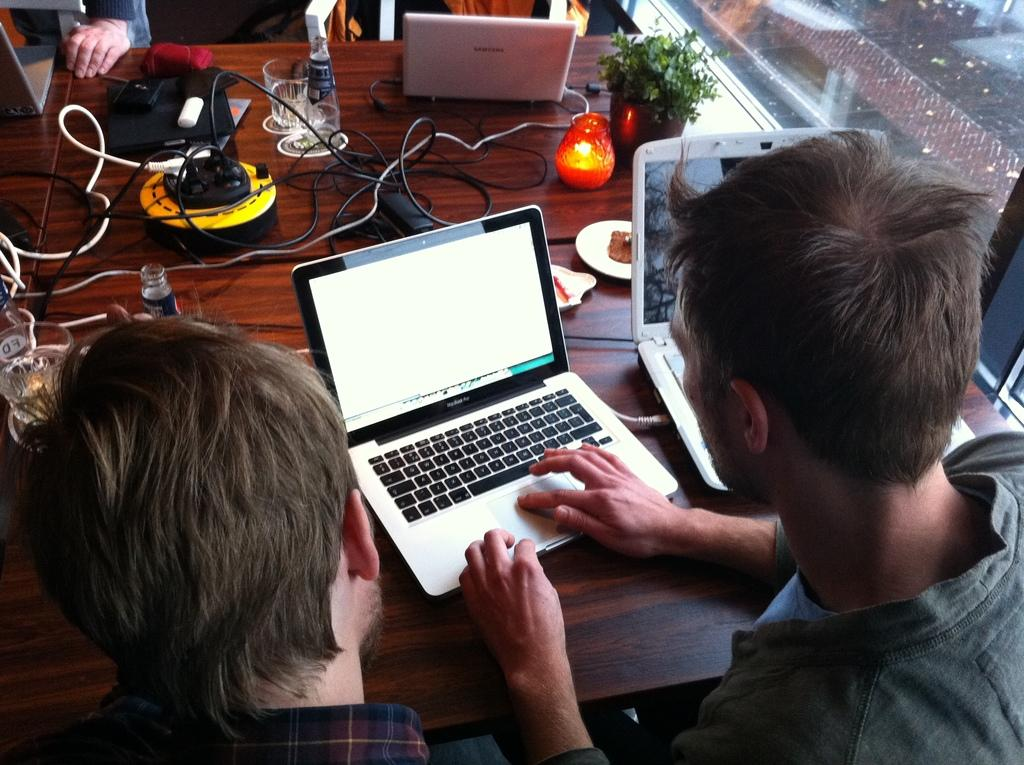What are the people in the image doing? The people in the image are sitting on chairs. What is present on the table in the image? There is a table in the image, and on it, there are laptops, a plant, a bottle, and glasses. How many laptops are on the table? There are laptops on the table, but the exact number is not specified in the facts. What type of object is present on the table that is not an electronic device or a plant? There is a bottle on the table, which is not an electronic device or a plant. What type of hat is the zephyr wearing in the image? There is no zephyr or hat present in the image. What part of the body is the plant on the table touching? The facts do not specify any information about the plant touching a body part. 